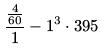Convert formula to latex. <formula><loc_0><loc_0><loc_500><loc_500>\frac { \frac { 4 } { 6 0 } } { 1 } - 1 ^ { 3 } \cdot 3 9 5</formula> 